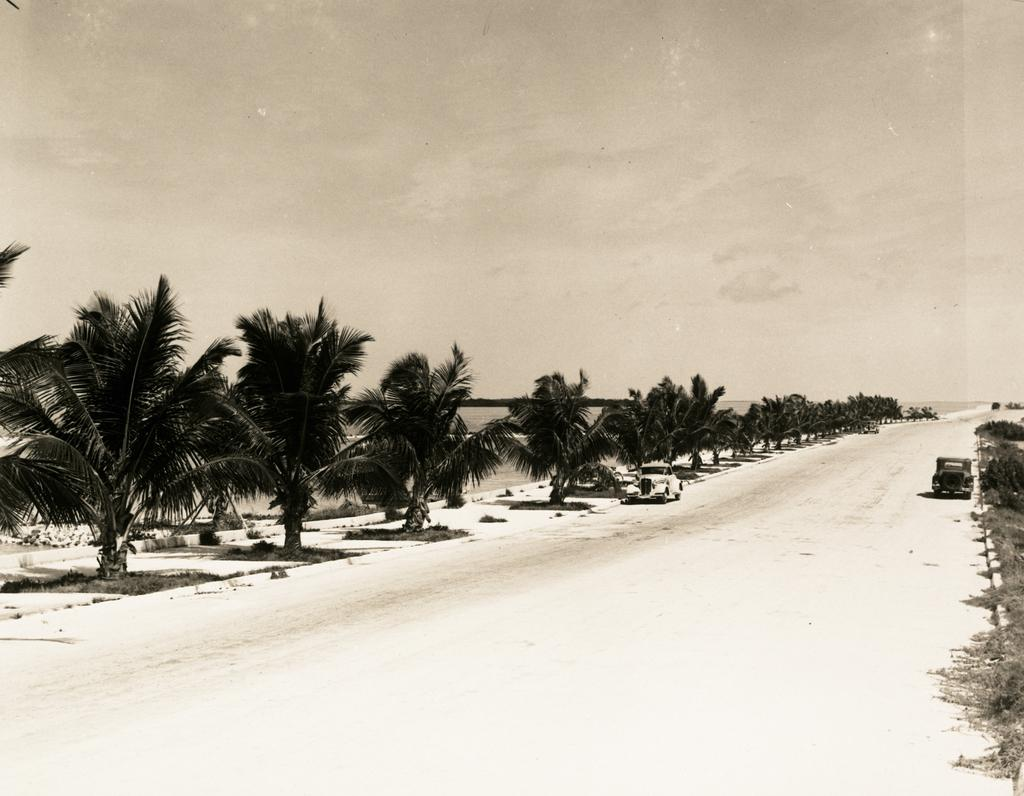What type of vegetation can be seen in the image? There are plants and trees in the image. What can be seen on the road in the image? There are vehicles on the road in the image. What is visible in the background of the image? Water and the sky are visible in the background of the image. What type of texture can be seen on the current in the image? There is no current present in the image, as it features plants, trees, vehicles, and a sky background. 